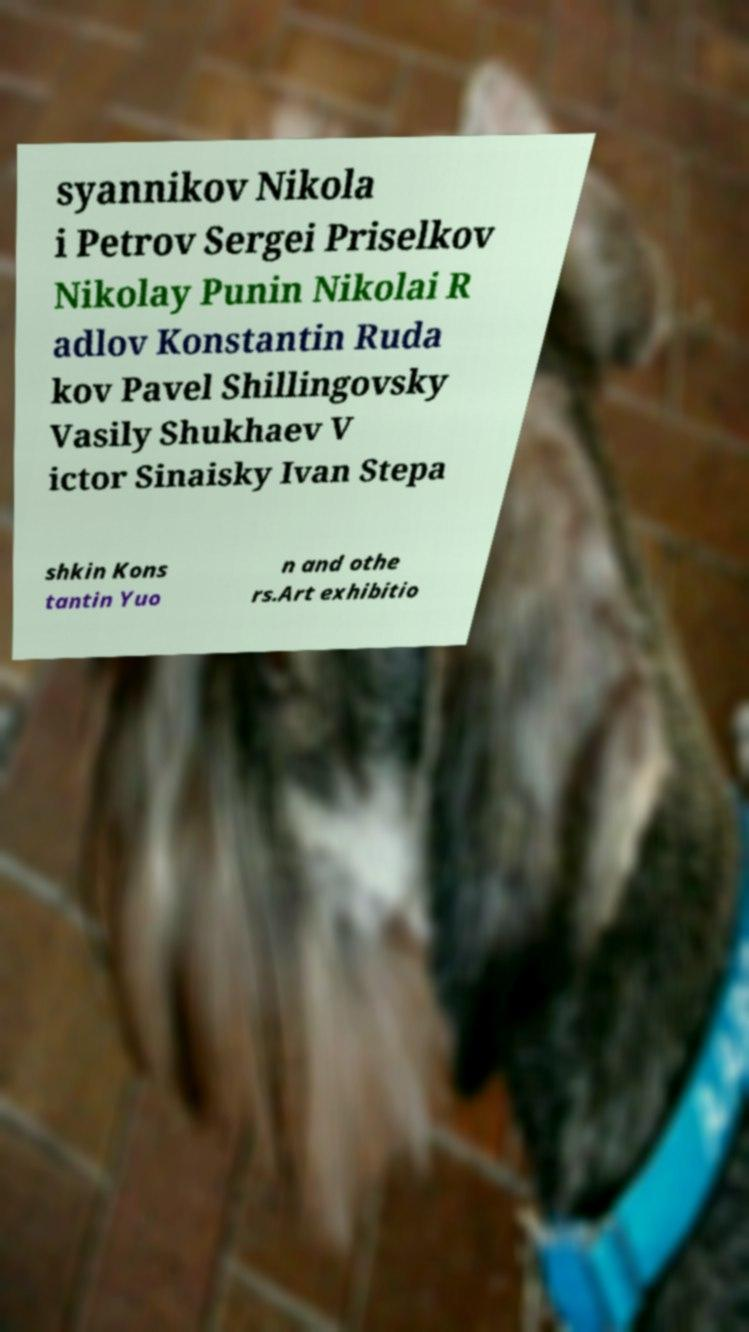Please identify and transcribe the text found in this image. syannikov Nikola i Petrov Sergei Priselkov Nikolay Punin Nikolai R adlov Konstantin Ruda kov Pavel Shillingovsky Vasily Shukhaev V ictor Sinaisky Ivan Stepa shkin Kons tantin Yuo n and othe rs.Art exhibitio 